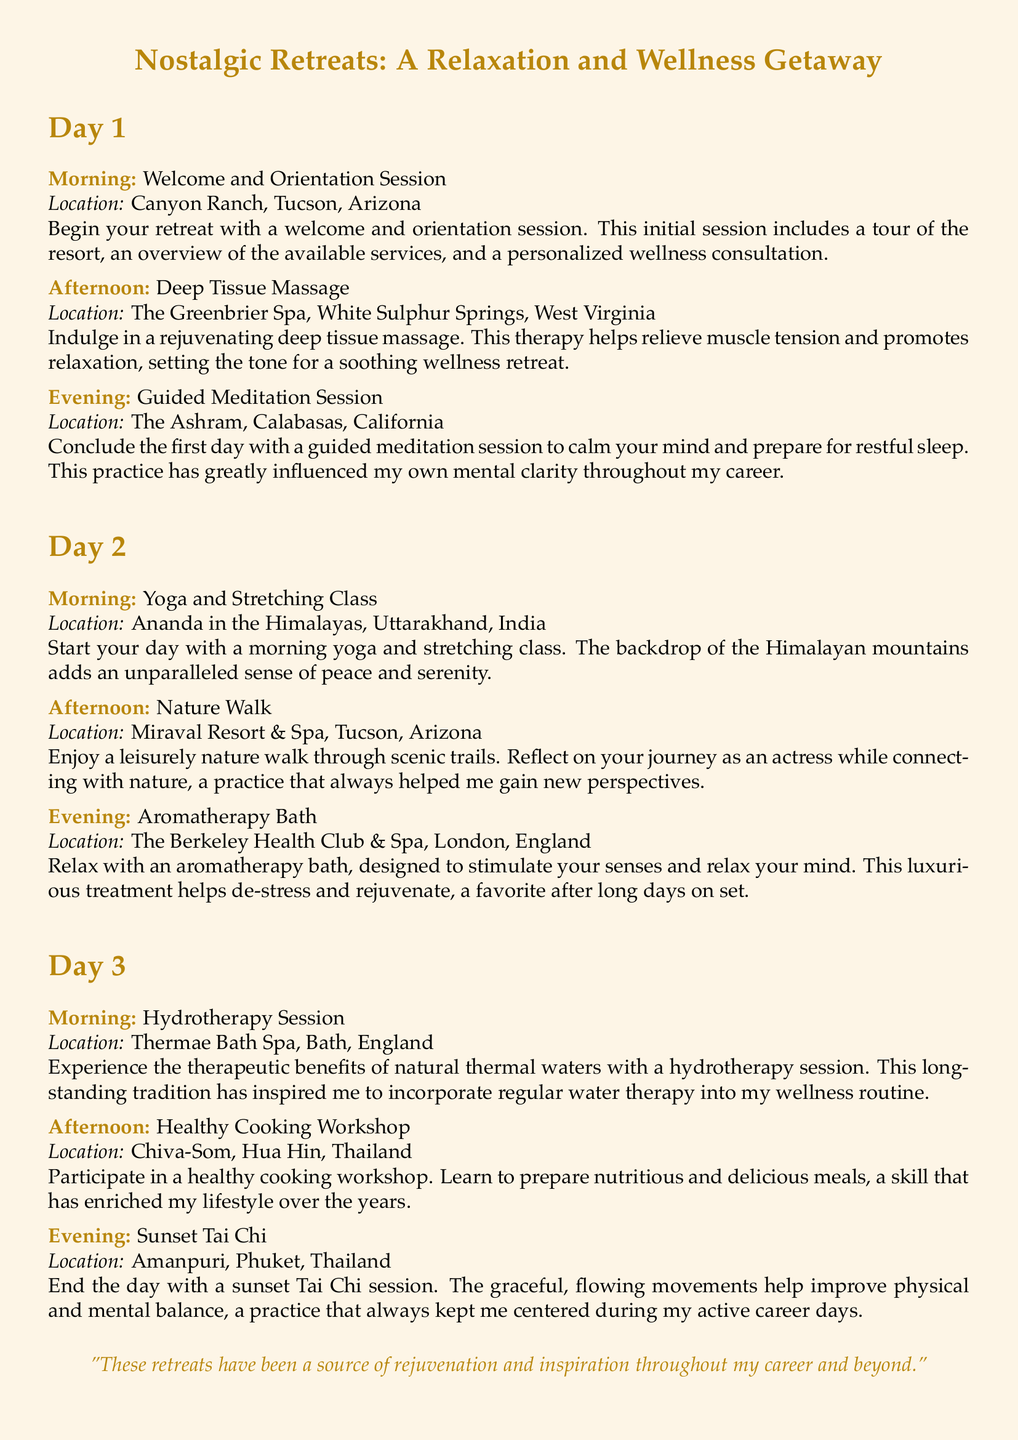What is the first activity on Day 1? The first activity on Day 1 is a welcome and orientation session.
Answer: Welcome and Orientation Session Where is the Deep Tissue Massage located? The Deep Tissue Massage takes place at The Greenbrier Spa.
Answer: The Greenbrier Spa What type of class is held on Day 2 morning? The class held on Day 2 morning is a yoga and stretching class.
Answer: Yoga and Stretching Class What therapeutic treatment does Day 3 morning feature? The therapeutic treatment featured on Day 3 morning is a hydrotherapy session.
Answer: Hydrotherapy Session What was the evening activity on Day 2? The evening activity on Day 2 is an aromatherapy bath.
Answer: Aromatherapy Bath How many days are outlined in the itinerary? The itinerary outlines activities for three days.
Answer: Three days What is one of the benefits of the sunset Tai Chi session? One of the benefits of the sunset Tai Chi session is improved balance.
Answer: Improved balance Which resort is associated with the Healthy Cooking Workshop? The resort associated with the Healthy Cooking Workshop is Chiva-Som.
Answer: Chiva-Som 